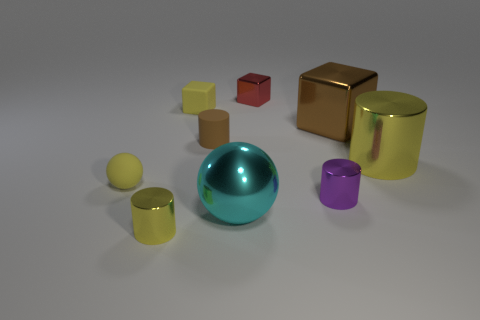Subtract all purple cylinders. How many cylinders are left? 3 Subtract all tiny rubber cylinders. How many cylinders are left? 3 Subtract all cyan cylinders. Subtract all yellow cubes. How many cylinders are left? 4 Add 1 red metallic things. How many objects exist? 10 Subtract all cylinders. How many objects are left? 5 Add 7 purple cylinders. How many purple cylinders are left? 8 Add 8 tiny rubber balls. How many tiny rubber balls exist? 9 Subtract 0 red cylinders. How many objects are left? 9 Subtract all small spheres. Subtract all small metallic blocks. How many objects are left? 7 